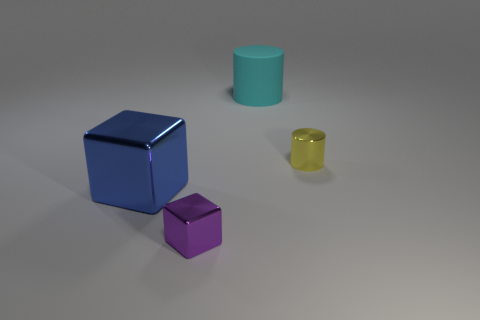Add 2 big matte objects. How many objects exist? 6 Add 3 large blue metal objects. How many large blue metal objects exist? 4 Subtract 0 gray cylinders. How many objects are left? 4 Subtract all cyan things. Subtract all large cyan rubber cylinders. How many objects are left? 2 Add 4 small purple blocks. How many small purple blocks are left? 5 